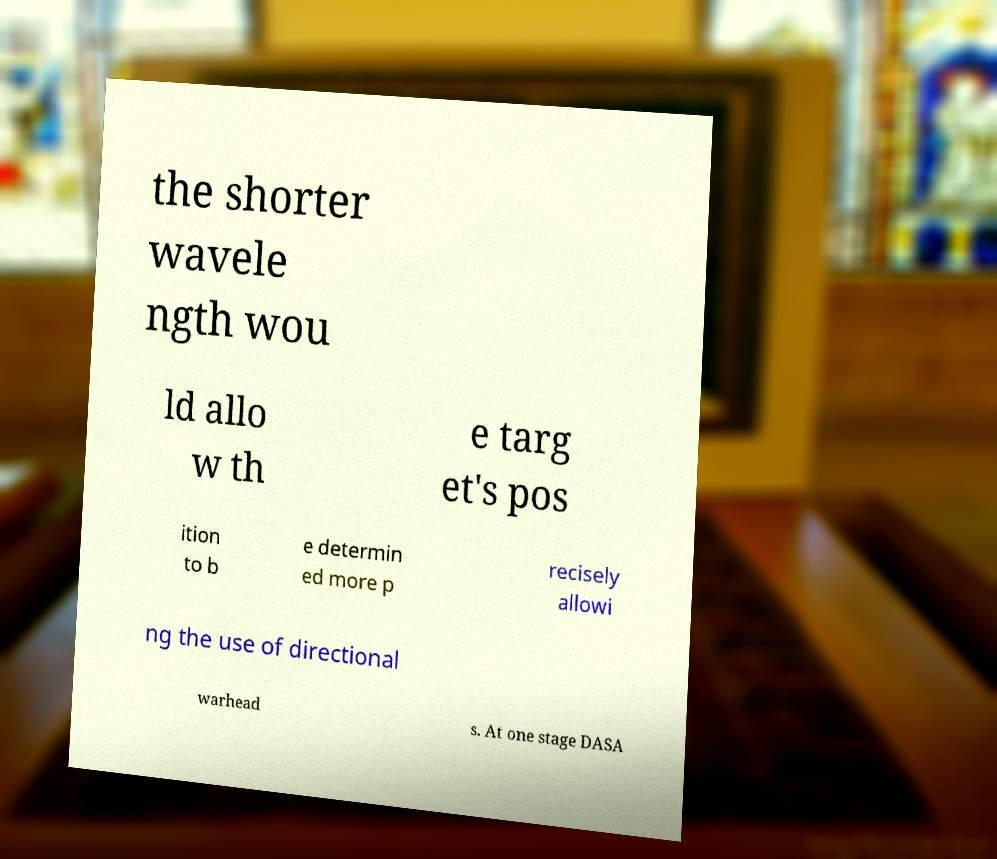Can you read and provide the text displayed in the image?This photo seems to have some interesting text. Can you extract and type it out for me? the shorter wavele ngth wou ld allo w th e targ et's pos ition to b e determin ed more p recisely allowi ng the use of directional warhead s. At one stage DASA 